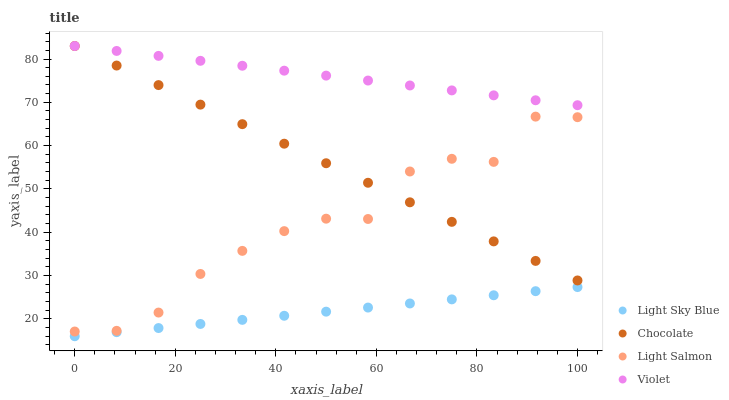Does Light Sky Blue have the minimum area under the curve?
Answer yes or no. Yes. Does Violet have the maximum area under the curve?
Answer yes or no. Yes. Does Light Salmon have the minimum area under the curve?
Answer yes or no. No. Does Light Salmon have the maximum area under the curve?
Answer yes or no. No. Is Light Sky Blue the smoothest?
Answer yes or no. Yes. Is Light Salmon the roughest?
Answer yes or no. Yes. Is Light Salmon the smoothest?
Answer yes or no. No. Is Light Sky Blue the roughest?
Answer yes or no. No. Does Light Sky Blue have the lowest value?
Answer yes or no. Yes. Does Light Salmon have the lowest value?
Answer yes or no. No. Does Chocolate have the highest value?
Answer yes or no. Yes. Does Light Salmon have the highest value?
Answer yes or no. No. Is Light Sky Blue less than Chocolate?
Answer yes or no. Yes. Is Chocolate greater than Light Sky Blue?
Answer yes or no. Yes. Does Chocolate intersect Light Salmon?
Answer yes or no. Yes. Is Chocolate less than Light Salmon?
Answer yes or no. No. Is Chocolate greater than Light Salmon?
Answer yes or no. No. Does Light Sky Blue intersect Chocolate?
Answer yes or no. No. 